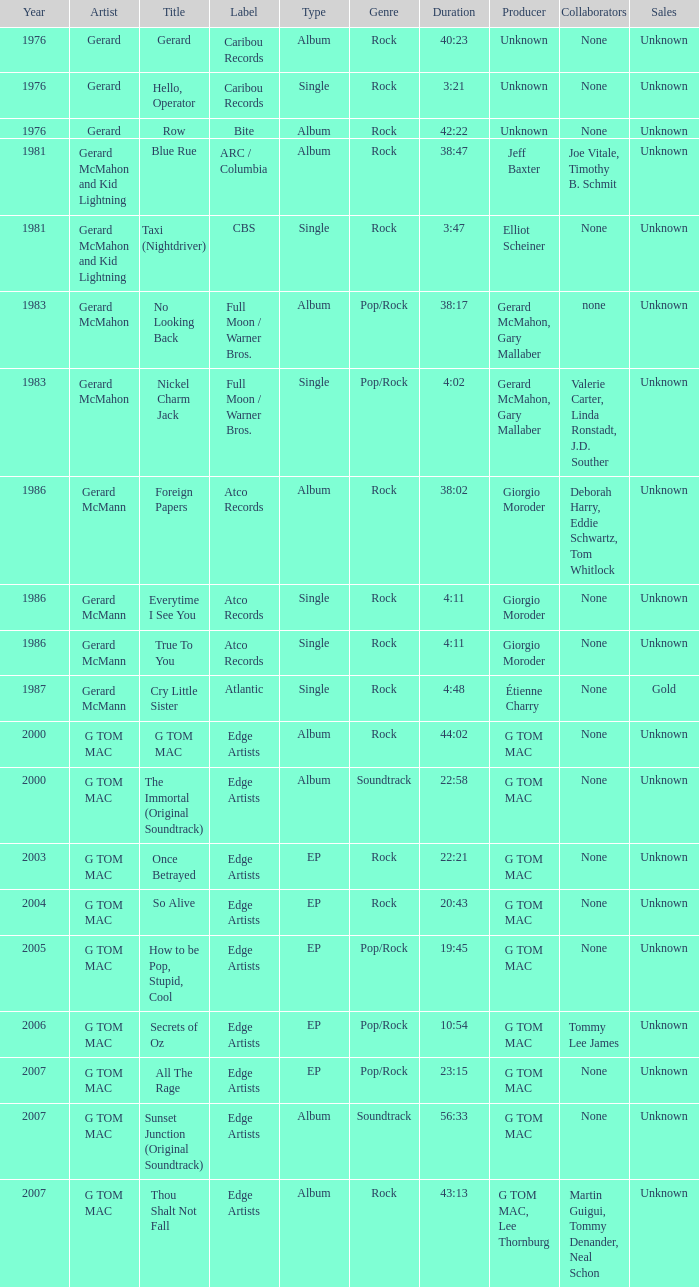Name the Year which has a Label of atco records and a Type of album? Question 2 1986.0. Could you parse the entire table? {'header': ['Year', 'Artist', 'Title', 'Label', 'Type', 'Genre', 'Duration', 'Producer', 'Collaborators', 'Sales'], 'rows': [['1976', 'Gerard', 'Gerard', 'Caribou Records', 'Album', 'Rock', '40:23', 'Unknown', 'None', 'Unknown'], ['1976', 'Gerard', 'Hello, Operator', 'Caribou Records', 'Single', 'Rock', '3:21', 'Unknown', 'None', 'Unknown'], ['1976', 'Gerard', 'Row', 'Bite', 'Album', 'Rock', '42:22', 'Unknown', 'None', 'Unknown'], ['1981', 'Gerard McMahon and Kid Lightning', 'Blue Rue', 'ARC / Columbia', 'Album', 'Rock', '38:47', 'Jeff Baxter', 'Joe Vitale, Timothy B. Schmit', 'Unknown'], ['1981', 'Gerard McMahon and Kid Lightning', 'Taxi (Nightdriver)', 'CBS', 'Single', 'Rock', '3:47', 'Elliot Scheiner', 'None', 'Unknown'], ['1983', 'Gerard McMahon', 'No Looking Back', 'Full Moon / Warner Bros.', 'Album', 'Pop/Rock', '38:17', 'Gerard McMahon, Gary Mallaber', 'none', 'Unknown'], ['1983', 'Gerard McMahon', 'Nickel Charm Jack', 'Full Moon / Warner Bros.', 'Single', 'Pop/Rock', '4:02', 'Gerard McMahon, Gary Mallaber', 'Valerie Carter, Linda Ronstadt, J.D. Souther', 'Unknown'], ['1986', 'Gerard McMann', 'Foreign Papers', 'Atco Records', 'Album', 'Rock', '38:02', 'Giorgio Moroder', 'Deborah Harry, Eddie Schwartz, Tom Whitlock', 'Unknown'], ['1986', 'Gerard McMann', 'Everytime I See You', 'Atco Records', 'Single', 'Rock', '4:11', 'Giorgio Moroder', 'None', 'Unknown'], ['1986', 'Gerard McMann', 'True To You', 'Atco Records', 'Single', 'Rock', '4:11', 'Giorgio Moroder', 'None', 'Unknown'], ['1987', 'Gerard McMann', 'Cry Little Sister', 'Atlantic', 'Single', 'Rock', '4:48', 'Étienne Charry', 'None', 'Gold'], ['2000', 'G TOM MAC', 'G TOM MAC', 'Edge Artists', 'Album', 'Rock', '44:02', 'G TOM MAC', 'None', 'Unknown'], ['2000', 'G TOM MAC', 'The Immortal (Original Soundtrack)', 'Edge Artists', 'Album', 'Soundtrack', '22:58', 'G TOM MAC', 'None', 'Unknown'], ['2003', 'G TOM MAC', 'Once Betrayed', 'Edge Artists', 'EP', 'Rock', '22:21', 'G TOM MAC', 'None', 'Unknown'], ['2004', 'G TOM MAC', 'So Alive', 'Edge Artists', 'EP', 'Rock', '20:43', 'G TOM MAC', 'None', 'Unknown'], ['2005', 'G TOM MAC', 'How to be Pop, Stupid, Cool', 'Edge Artists', 'EP', 'Pop/Rock', '19:45', 'G TOM MAC', 'None', 'Unknown'], ['2006', 'G TOM MAC', 'Secrets of Oz', 'Edge Artists', 'EP', 'Pop/Rock', '10:54', 'G TOM MAC', 'Tommy Lee James', 'Unknown'], ['2007', 'G TOM MAC', 'All The Rage', 'Edge Artists', 'EP', 'Pop/Rock', '23:15', 'G TOM MAC', 'None', 'Unknown'], ['2007', 'G TOM MAC', 'Sunset Junction (Original Soundtrack)', 'Edge Artists', 'Album', 'Soundtrack', '56:33', 'G TOM MAC', 'None', 'Unknown'], ['2007', 'G TOM MAC', 'Thou Shalt Not Fall', 'Edge Artists', 'Album', 'Rock', '43:13', 'G TOM MAC, Lee Thornburg', 'Martin Guigui, Tommy Denander, Neal Schon', 'Unknown']]} 